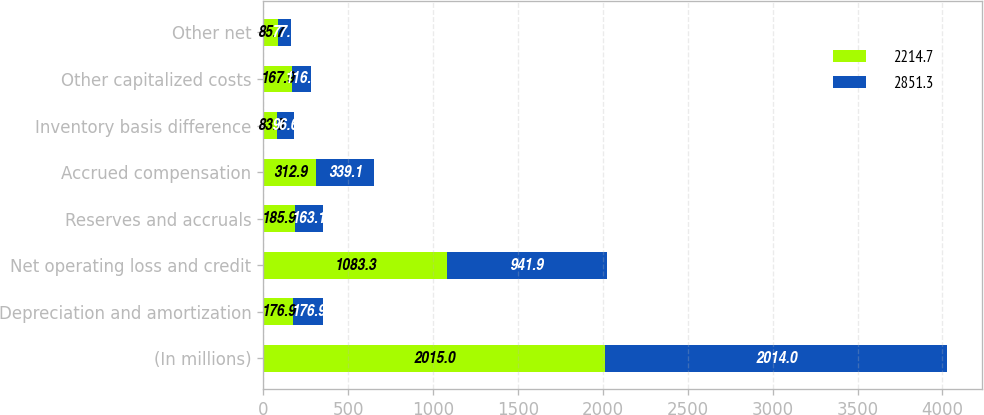Convert chart. <chart><loc_0><loc_0><loc_500><loc_500><stacked_bar_chart><ecel><fcel>(In millions)<fcel>Depreciation and amortization<fcel>Net operating loss and credit<fcel>Reserves and accruals<fcel>Accrued compensation<fcel>Inventory basis difference<fcel>Other capitalized costs<fcel>Other net<nl><fcel>2214.7<fcel>2015<fcel>176.9<fcel>1083.3<fcel>185.9<fcel>312.9<fcel>83.3<fcel>167.9<fcel>85.7<nl><fcel>2851.3<fcel>2014<fcel>176.9<fcel>941.9<fcel>163.1<fcel>339.1<fcel>96.6<fcel>116<fcel>77<nl></chart> 